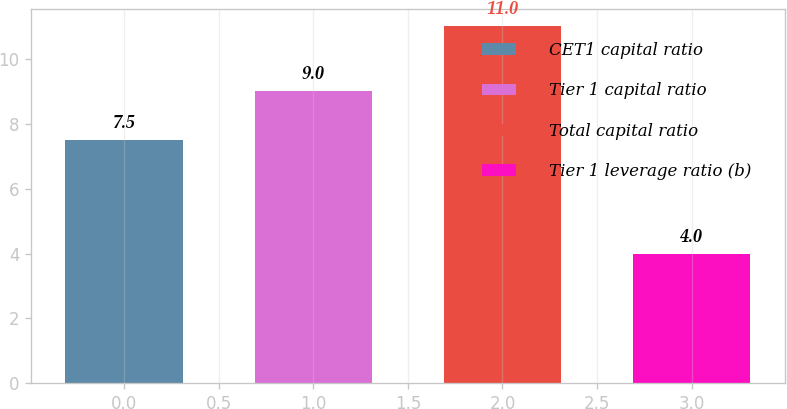<chart> <loc_0><loc_0><loc_500><loc_500><bar_chart><fcel>CET1 capital ratio<fcel>Tier 1 capital ratio<fcel>Total capital ratio<fcel>Tier 1 leverage ratio (b)<nl><fcel>7.5<fcel>9<fcel>11<fcel>4<nl></chart> 